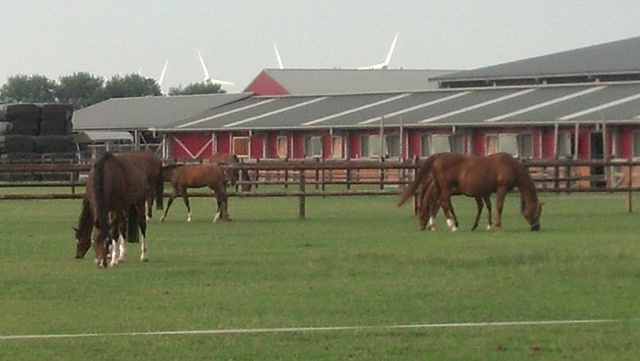Describe the objects in this image and their specific colors. I can see horse in lightgray, black, maroon, and gray tones, horse in lightgray, maroon, black, and gray tones, horse in lightgray, maroon, black, and gray tones, horse in lightgray, black, gray, and darkgreen tones, and horse in lightgray, gray, black, and maroon tones in this image. 